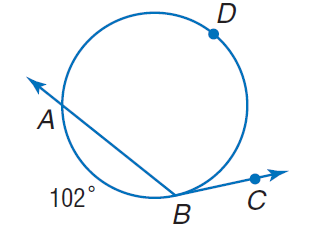Question: Find m \angle A B C if m \widehat A B = 102.
Choices:
A. 102
B. 129
C. 204
D. 306
Answer with the letter. Answer: B 